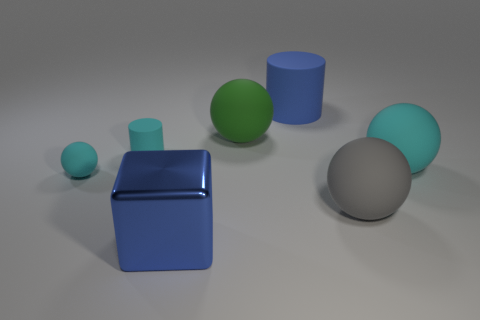What number of shiny cubes are the same color as the big matte cylinder?
Ensure brevity in your answer.  1. What number of other things are there of the same material as the gray thing
Offer a terse response. 5. Is the number of tiny cyan cylinders that are in front of the large blue metal object the same as the number of balls that are on the left side of the tiny rubber cylinder?
Provide a short and direct response. No. What number of cyan things are small rubber cylinders or rubber objects?
Your answer should be very brief. 3. There is a big metallic cube; is its color the same as the small matte sphere on the left side of the big blue metal block?
Ensure brevity in your answer.  No. What number of other objects are there of the same color as the big block?
Make the answer very short. 1. Are there fewer cyan matte cylinders than tiny red matte cylinders?
Provide a short and direct response. No. How many small cyan cylinders are in front of the blue object behind the cyan rubber sphere that is left of the big gray sphere?
Your answer should be compact. 1. There is a cylinder that is behind the large green matte ball; what size is it?
Offer a terse response. Large. Is the shape of the big matte thing that is on the left side of the blue cylinder the same as  the large gray rubber thing?
Give a very brief answer. Yes. 